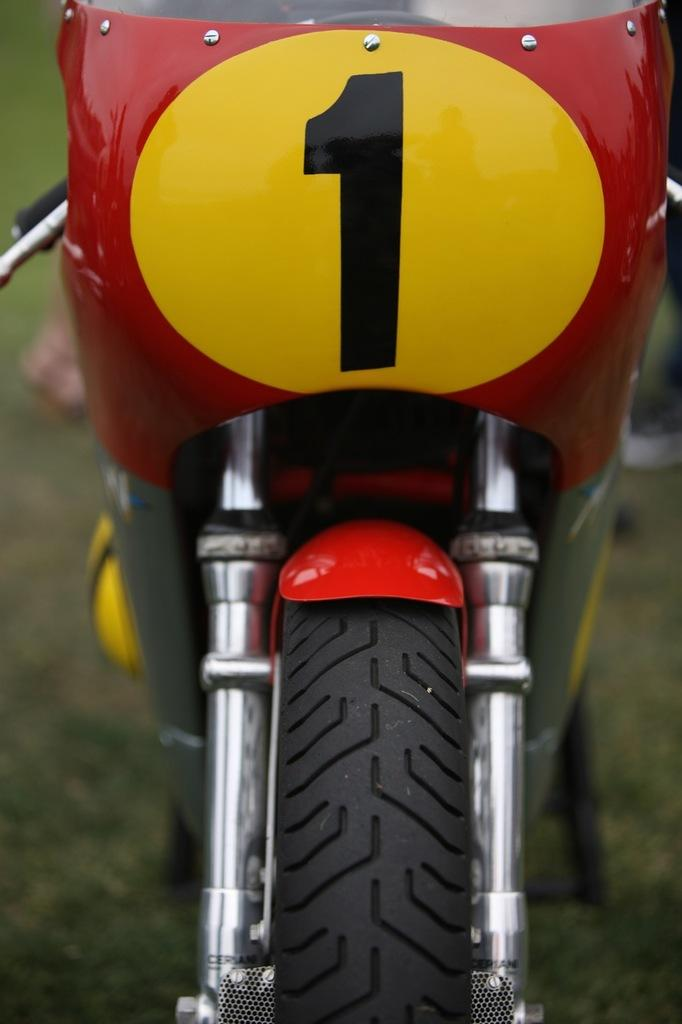What type of vehicle is in the image? There is a motorcycle in the image. What can be said about the color of the motorcycle? The front part of the motorcycle is in red and yellow colors. How many worms can be seen crawling on the motorcycle in the image? There are no worms present in the image; it only features a motorcycle with red and yellow colors. 